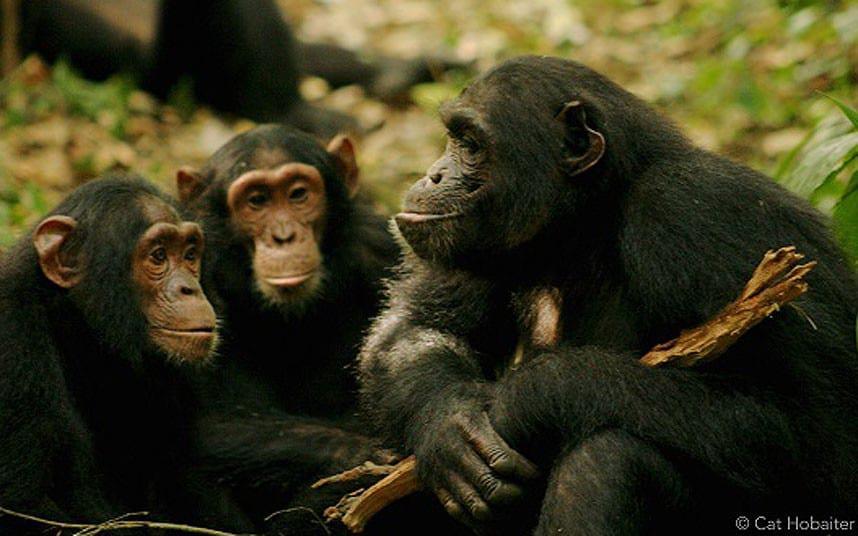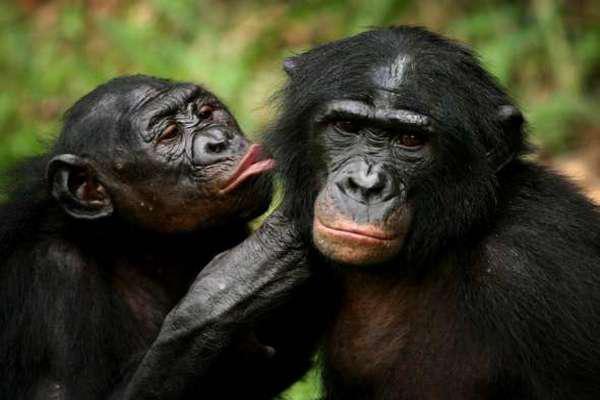The first image is the image on the left, the second image is the image on the right. Analyze the images presented: Is the assertion "In one image, two chimpanzees are hugging, while one chimpanzee in a second image has its left arm raised to head level." valid? Answer yes or no. No. The first image is the image on the left, the second image is the image on the right. Evaluate the accuracy of this statement regarding the images: "An image shows an adult and a younger chimp chest to chest in a hugging pose.". Is it true? Answer yes or no. No. 